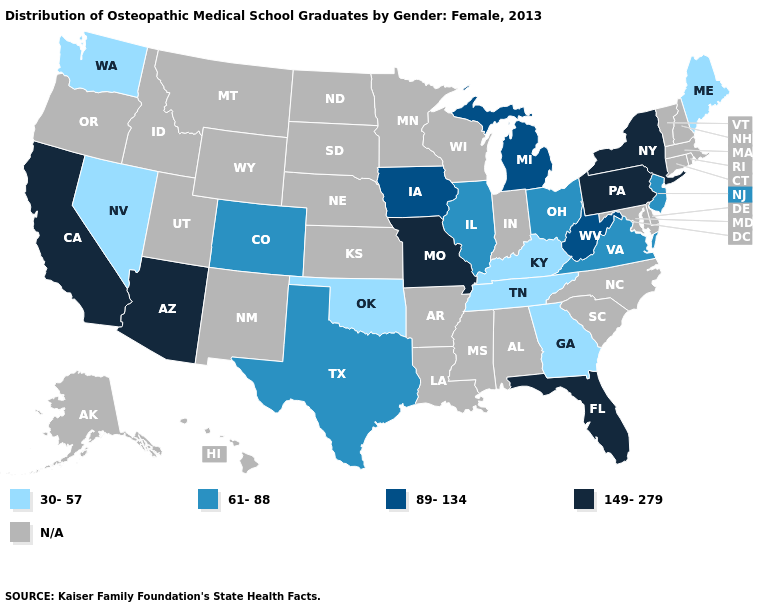What is the value of North Dakota?
Quick response, please. N/A. What is the value of Connecticut?
Concise answer only. N/A. Does Maine have the lowest value in the USA?
Concise answer only. Yes. Name the states that have a value in the range 30-57?
Quick response, please. Georgia, Kentucky, Maine, Nevada, Oklahoma, Tennessee, Washington. Which states have the highest value in the USA?
Be succinct. Arizona, California, Florida, Missouri, New York, Pennsylvania. What is the highest value in the USA?
Answer briefly. 149-279. Does the first symbol in the legend represent the smallest category?
Concise answer only. Yes. Name the states that have a value in the range 61-88?
Keep it brief. Colorado, Illinois, New Jersey, Ohio, Texas, Virginia. Which states have the lowest value in the USA?
Concise answer only. Georgia, Kentucky, Maine, Nevada, Oklahoma, Tennessee, Washington. Does New Jersey have the lowest value in the Northeast?
Keep it brief. No. What is the lowest value in the West?
Short answer required. 30-57. Which states hav the highest value in the Northeast?
Short answer required. New York, Pennsylvania. Name the states that have a value in the range 61-88?
Short answer required. Colorado, Illinois, New Jersey, Ohio, Texas, Virginia. What is the highest value in the Northeast ?
Be succinct. 149-279. 